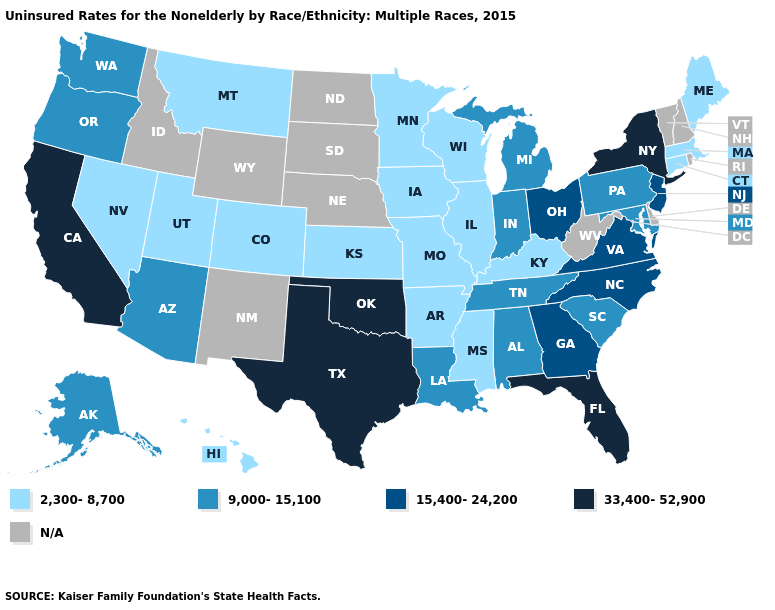Which states have the lowest value in the USA?
Write a very short answer. Arkansas, Colorado, Connecticut, Hawaii, Illinois, Iowa, Kansas, Kentucky, Maine, Massachusetts, Minnesota, Mississippi, Missouri, Montana, Nevada, Utah, Wisconsin. Which states hav the highest value in the West?
Short answer required. California. How many symbols are there in the legend?
Write a very short answer. 5. What is the value of New Hampshire?
Be succinct. N/A. Does the first symbol in the legend represent the smallest category?
Short answer required. Yes. What is the highest value in states that border Oklahoma?
Concise answer only. 33,400-52,900. Does Missouri have the highest value in the MidWest?
Concise answer only. No. Does the first symbol in the legend represent the smallest category?
Be succinct. Yes. Does the map have missing data?
Quick response, please. Yes. Name the states that have a value in the range 9,000-15,100?
Be succinct. Alabama, Alaska, Arizona, Indiana, Louisiana, Maryland, Michigan, Oregon, Pennsylvania, South Carolina, Tennessee, Washington. Name the states that have a value in the range 9,000-15,100?
Short answer required. Alabama, Alaska, Arizona, Indiana, Louisiana, Maryland, Michigan, Oregon, Pennsylvania, South Carolina, Tennessee, Washington. Which states have the lowest value in the South?
Short answer required. Arkansas, Kentucky, Mississippi. What is the lowest value in the Northeast?
Be succinct. 2,300-8,700. Does Oklahoma have the highest value in the USA?
Be succinct. Yes. Which states have the lowest value in the West?
Be succinct. Colorado, Hawaii, Montana, Nevada, Utah. 